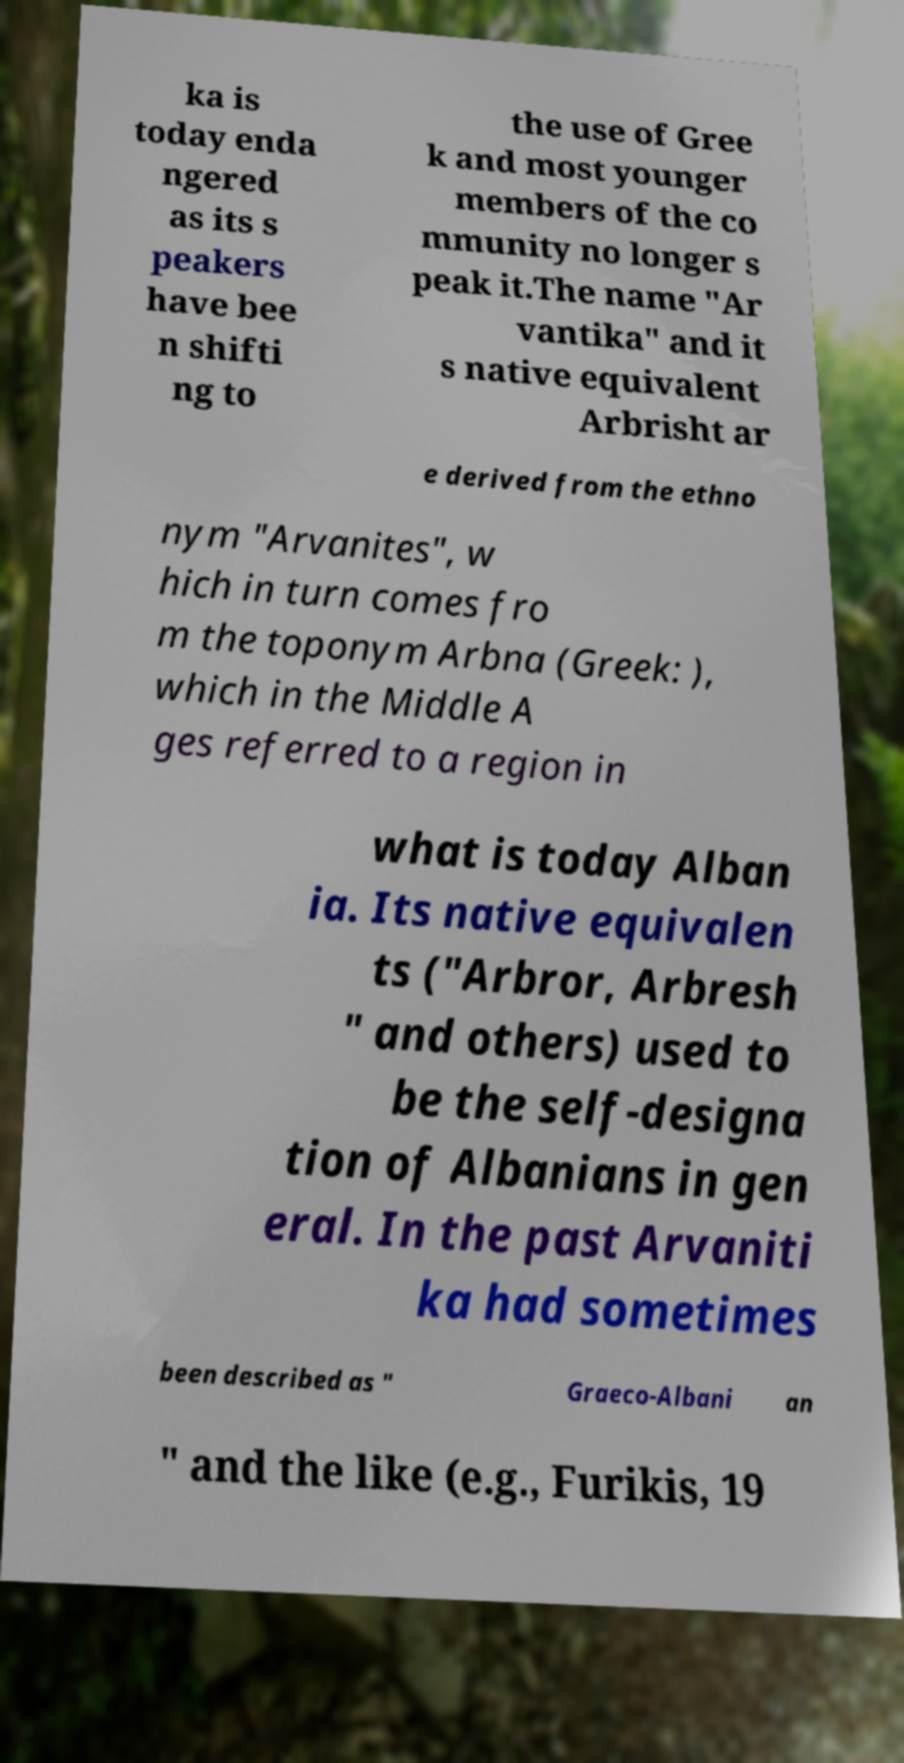Can you accurately transcribe the text from the provided image for me? ka is today enda ngered as its s peakers have bee n shifti ng to the use of Gree k and most younger members of the co mmunity no longer s peak it.The name "Ar vantika" and it s native equivalent Arbrisht ar e derived from the ethno nym "Arvanites", w hich in turn comes fro m the toponym Arbna (Greek: ), which in the Middle A ges referred to a region in what is today Alban ia. Its native equivalen ts ("Arbror, Arbresh " and others) used to be the self-designa tion of Albanians in gen eral. In the past Arvaniti ka had sometimes been described as " Graeco-Albani an " and the like (e.g., Furikis, 19 